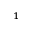<formula> <loc_0><loc_0><loc_500><loc_500>^ { 1 }</formula> 